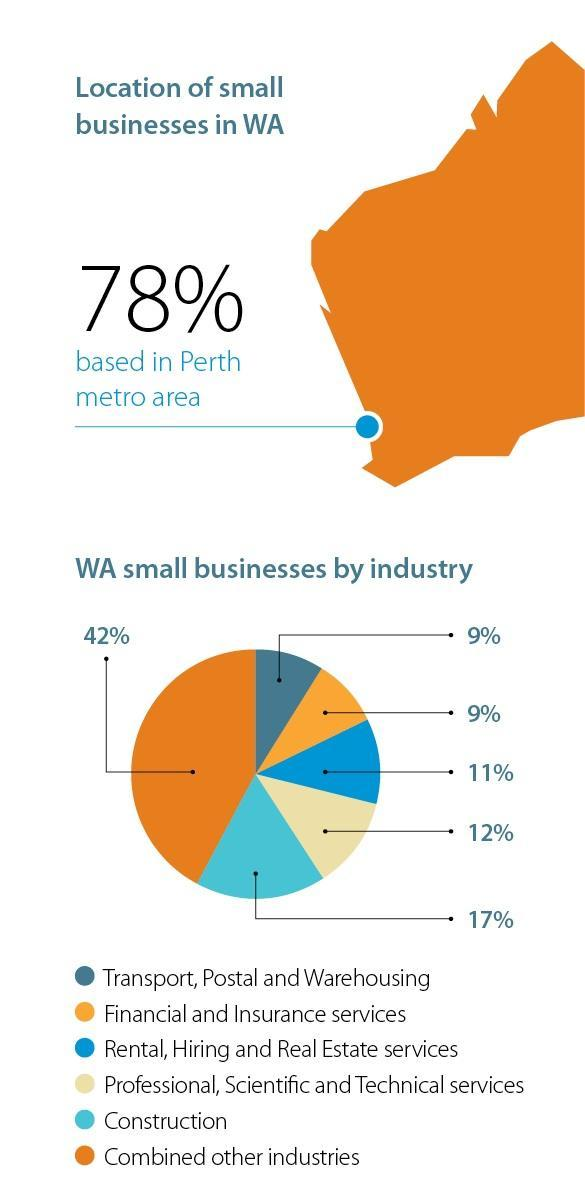tranport, postal and warehousing industry is the same volume as which other industry
Answer the question with a short phrase. financial and insurance services How much less in % is the professional, scientific and technical service than construction 5 what is the total % of construction and combined other industries 59 